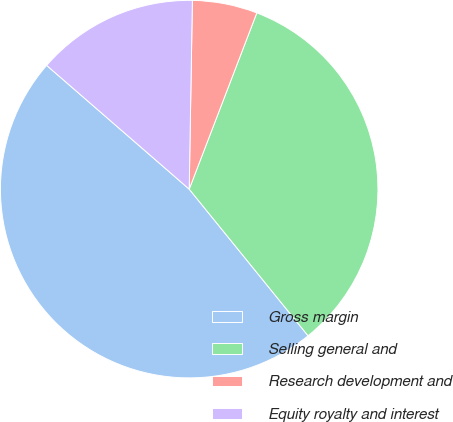Convert chart to OTSL. <chart><loc_0><loc_0><loc_500><loc_500><pie_chart><fcel>Gross margin<fcel>Selling general and<fcel>Research development and<fcel>Equity royalty and interest<nl><fcel>47.22%<fcel>33.33%<fcel>5.56%<fcel>13.89%<nl></chart> 